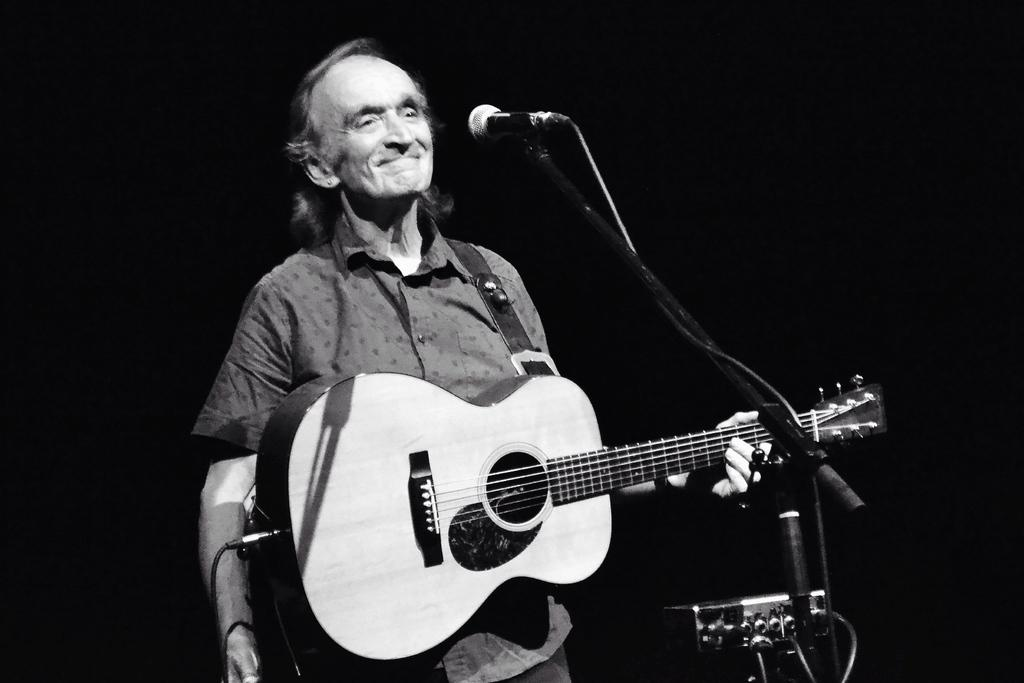What is the man in the image holding? The man is holding a guitar. What expression does the man have in the image? The man is smiling. What is the man standing in front of in the image? The man is standing in front of a microphone. What object can be seen in the image that is used to hold something up? There is a stand in the image. How would you describe the lighting in the image? The background of the image is dark. What type of can is visible in the image? There is no can present in the image. Can you see any sinks in the image? There are no sinks present in the image. Are there any trains visible in the image? There are no trains present in the image. 